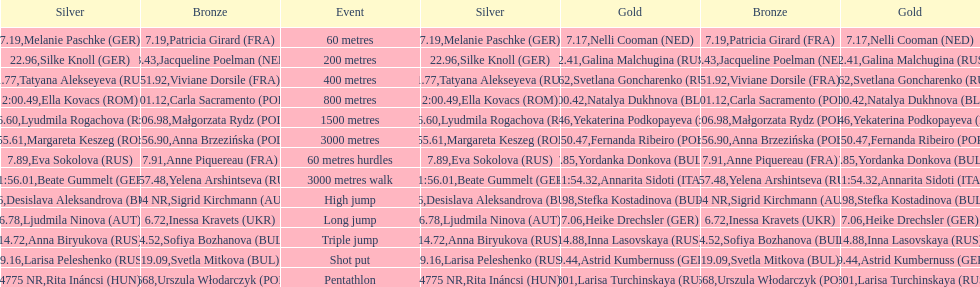How many german women won medals? 5. 